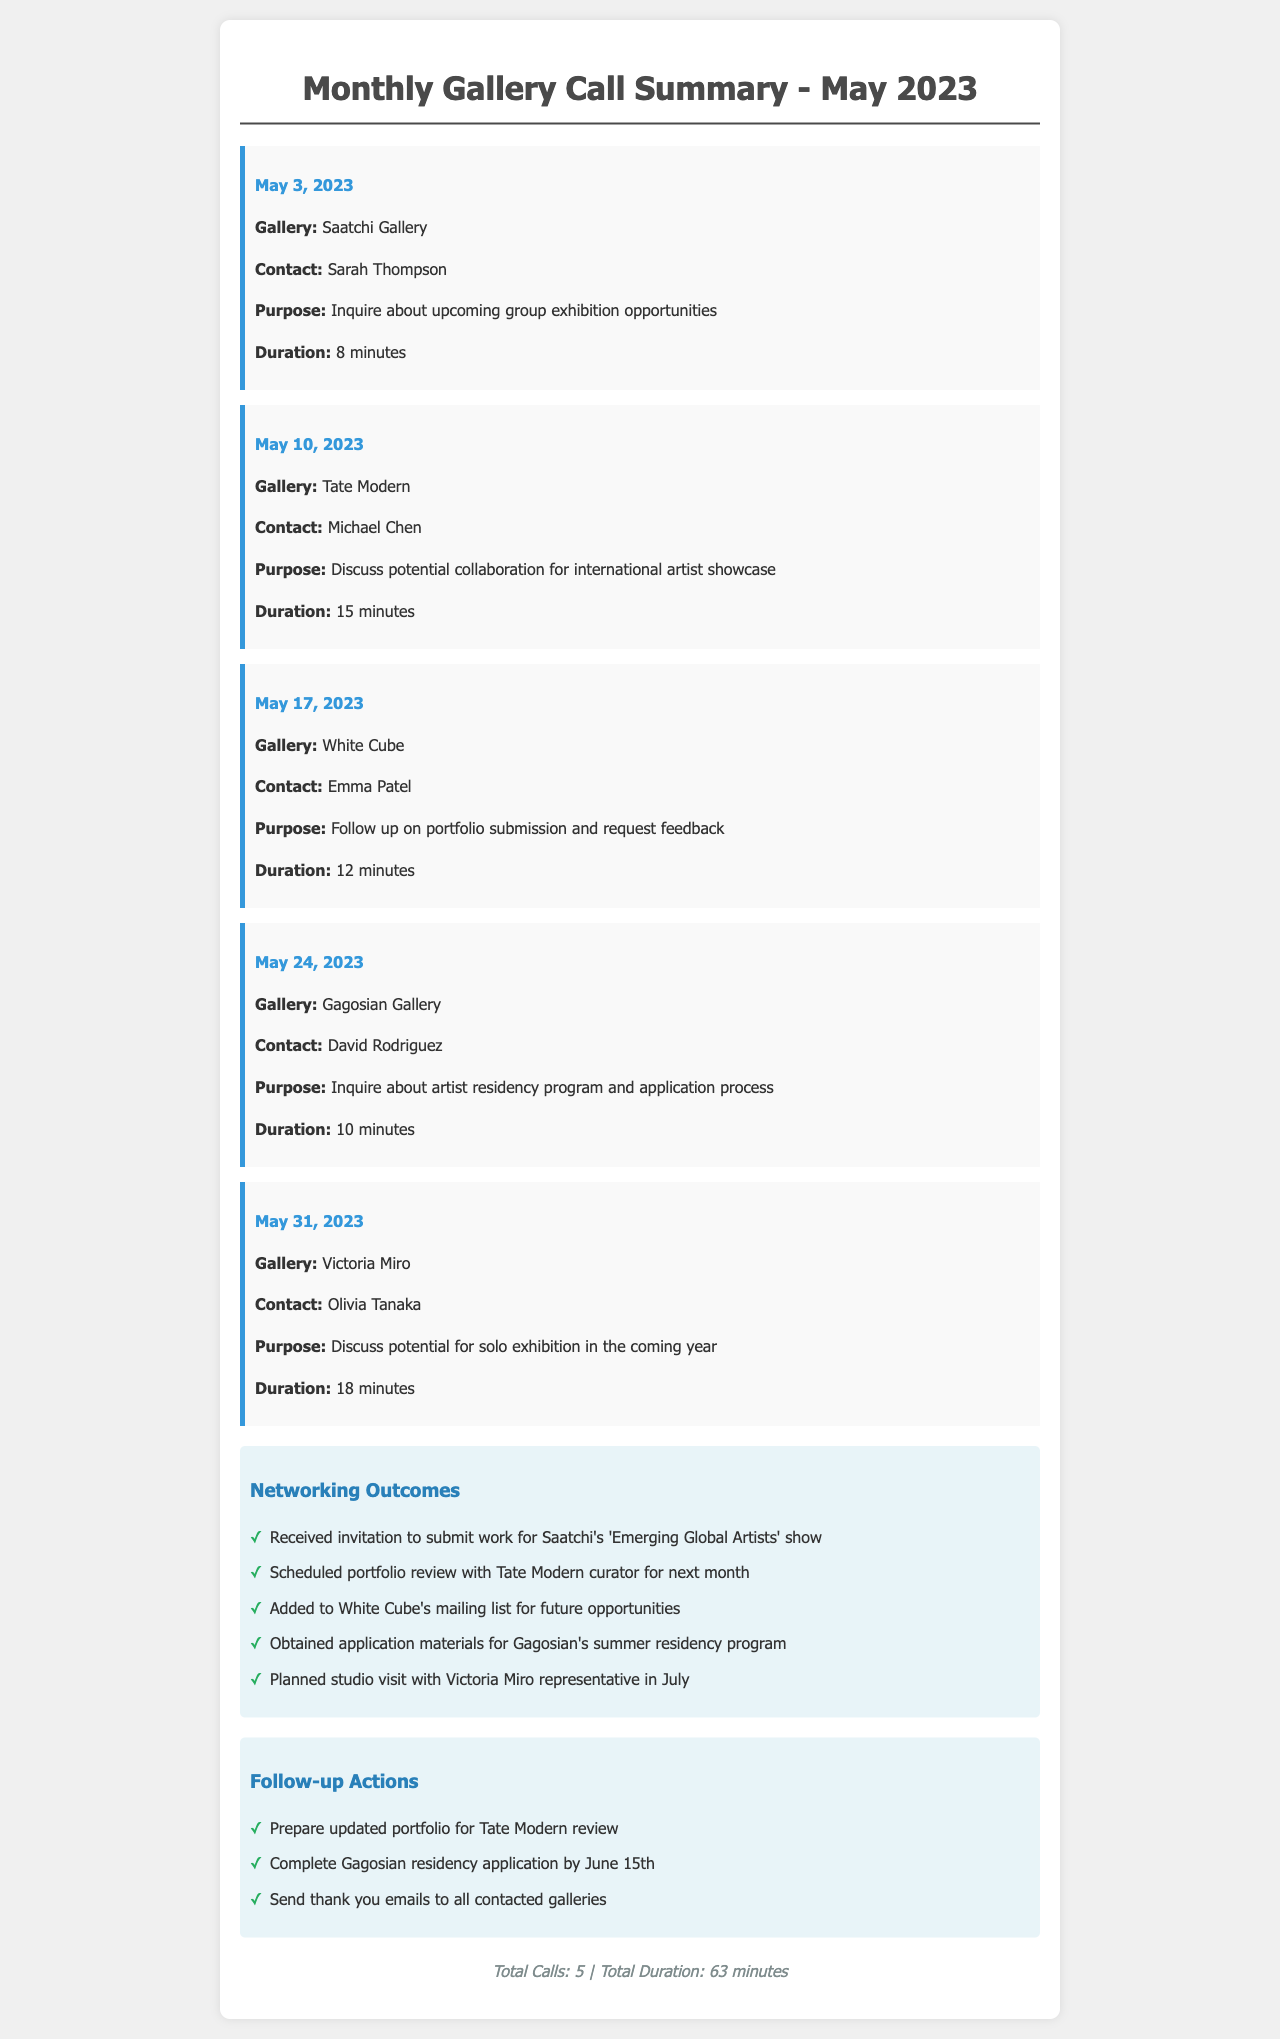What is the date of the first call? The first call is recorded on May 3, 2023.
Answer: May 3, 2023 Who did you speak to at the Tate Modern? The contact at Tate Modern was Michael Chen.
Answer: Michael Chen What was the total duration of all calls? The duration is listed as 63 minutes from all five calls combined.
Answer: 63 minutes Which gallery's residency program was inquired about? The inquiry was made about Gagosian Gallery's artist residency program.
Answer: Gagosian Gallery How many calls were made to galleries in May 2023? The document states that a total of 5 calls were made.
Answer: 5 What follow-up action is needed by June 15th? The action required is to complete the Gagosian residency application.
Answer: Gagosian residency application What was the purpose of the call on May 31, 2023? The purpose was to discuss the potential for a solo exhibition.
Answer: Discuss potential for solo exhibition Which gallery scheduled a portfolio review? The Tate Modern has scheduled a portfolio review for next month.
Answer: Tate Modern 